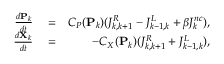Convert formula to latex. <formula><loc_0><loc_0><loc_500><loc_500>\begin{array} { r l r } { \frac { d P _ { k } } { d t } } & = } & { C _ { P } ( P _ { k } ) ( J _ { k , k + 1 } ^ { R } - J _ { k - 1 , k } ^ { L } + \beta J _ { k } ^ { n c } ) , } \\ { \frac { d X _ { k } } { d t } } & = } & { - C _ { X } ( P _ { k } ) ( J _ { k , k + 1 } ^ { R } + J _ { k - 1 , k } ^ { L } ) , } \end{array}</formula> 